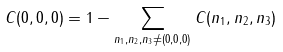<formula> <loc_0><loc_0><loc_500><loc_500>C ( 0 , 0 , 0 ) = 1 - \sum _ { n _ { 1 } , n _ { 2 } , n _ { 3 } \ne ( 0 , 0 , 0 ) } C ( n _ { 1 } , n _ { 2 } , n _ { 3 } )</formula> 